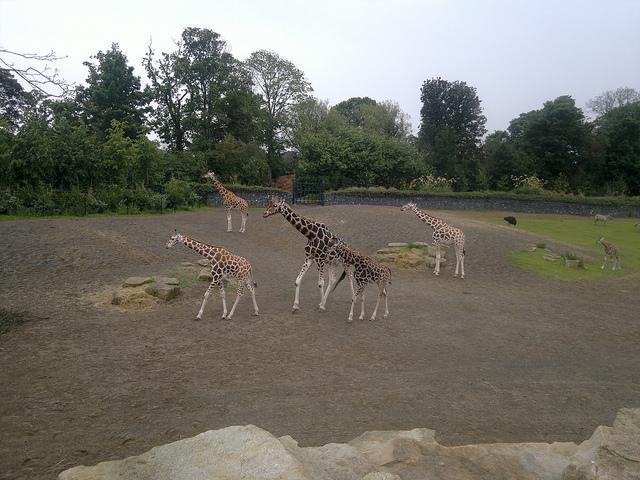How many lions in the picture?
Give a very brief answer. 0. How many giraffes are there?
Give a very brief answer. 5. 